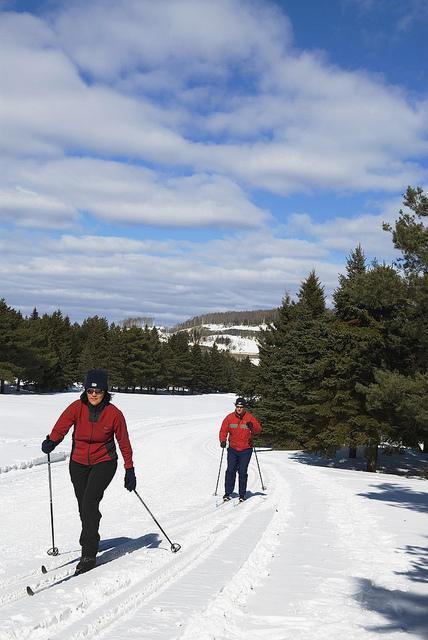What action are the people taking?
Select the accurate answer and provide explanation: 'Answer: answer
Rationale: rationale.'
Options: Falling, descend, riding, ascend. Answer: ascend.
Rationale: The people ascend. 